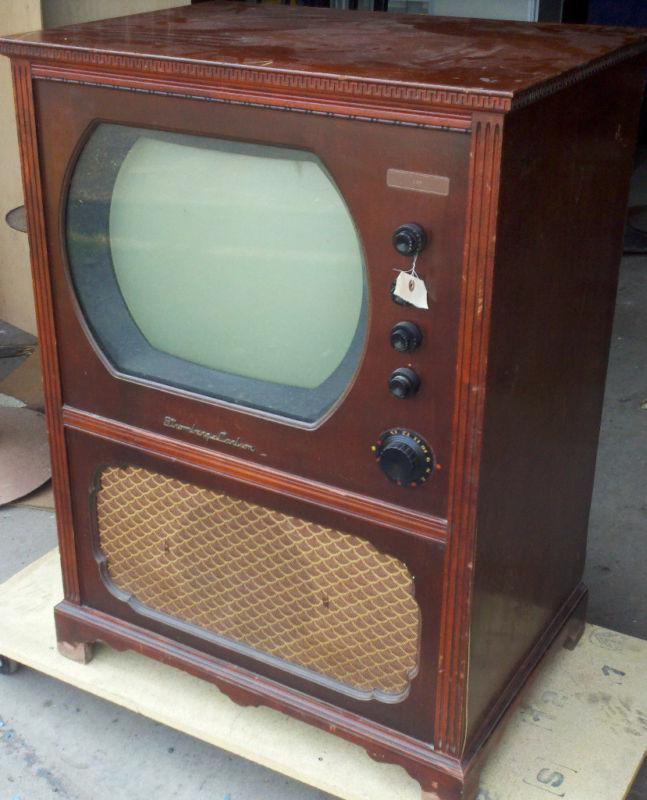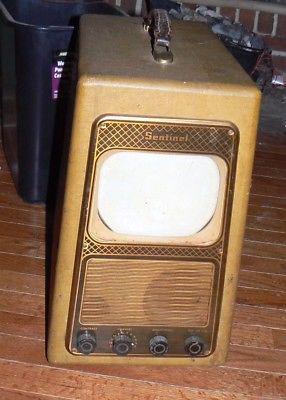The first image is the image on the left, the second image is the image on the right. Assess this claim about the two images: "In at least one image there is a small rectangle tv sitting on a white table.". Correct or not? Answer yes or no. No. The first image is the image on the left, the second image is the image on the right. Evaluate the accuracy of this statement regarding the images: "A television is turned on.". Is it true? Answer yes or no. No. 